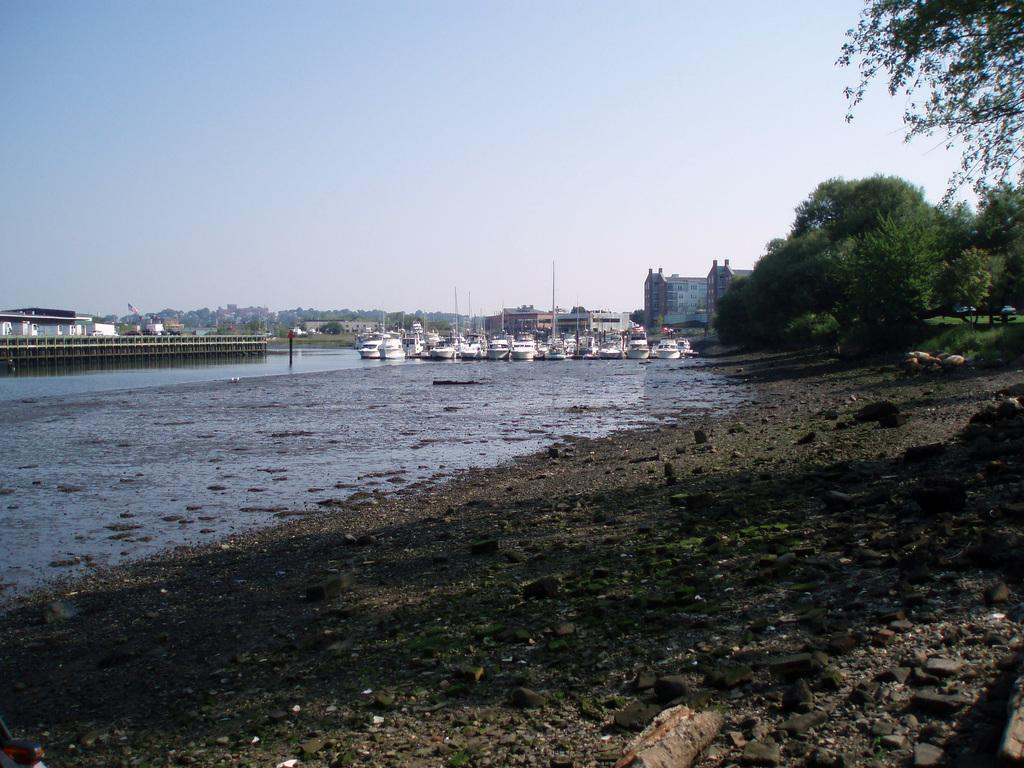What is the primary element visible in the image? There is water in the image. What types of vehicles can be seen in the image? There are ships in the image. What is visible beneath the water? The ground is visible in the image. What type of vegetation is present in the image? There are trees in the image. What type of man-made structures are visible in the image? There are buildings in the image. What type of vertical structures are present in the image? There are poles in the image. Are there any other objects visible in the image that are not specified? Yes, there are unspecified objects in the image. What is visible in the background of the image? The sky is visible in the background of the image. What type of tail can be seen on the animals in the image? There are no animals with tails present in the image. What type of scarf is being worn by the person in the image? There is no person wearing a scarf in the image. 